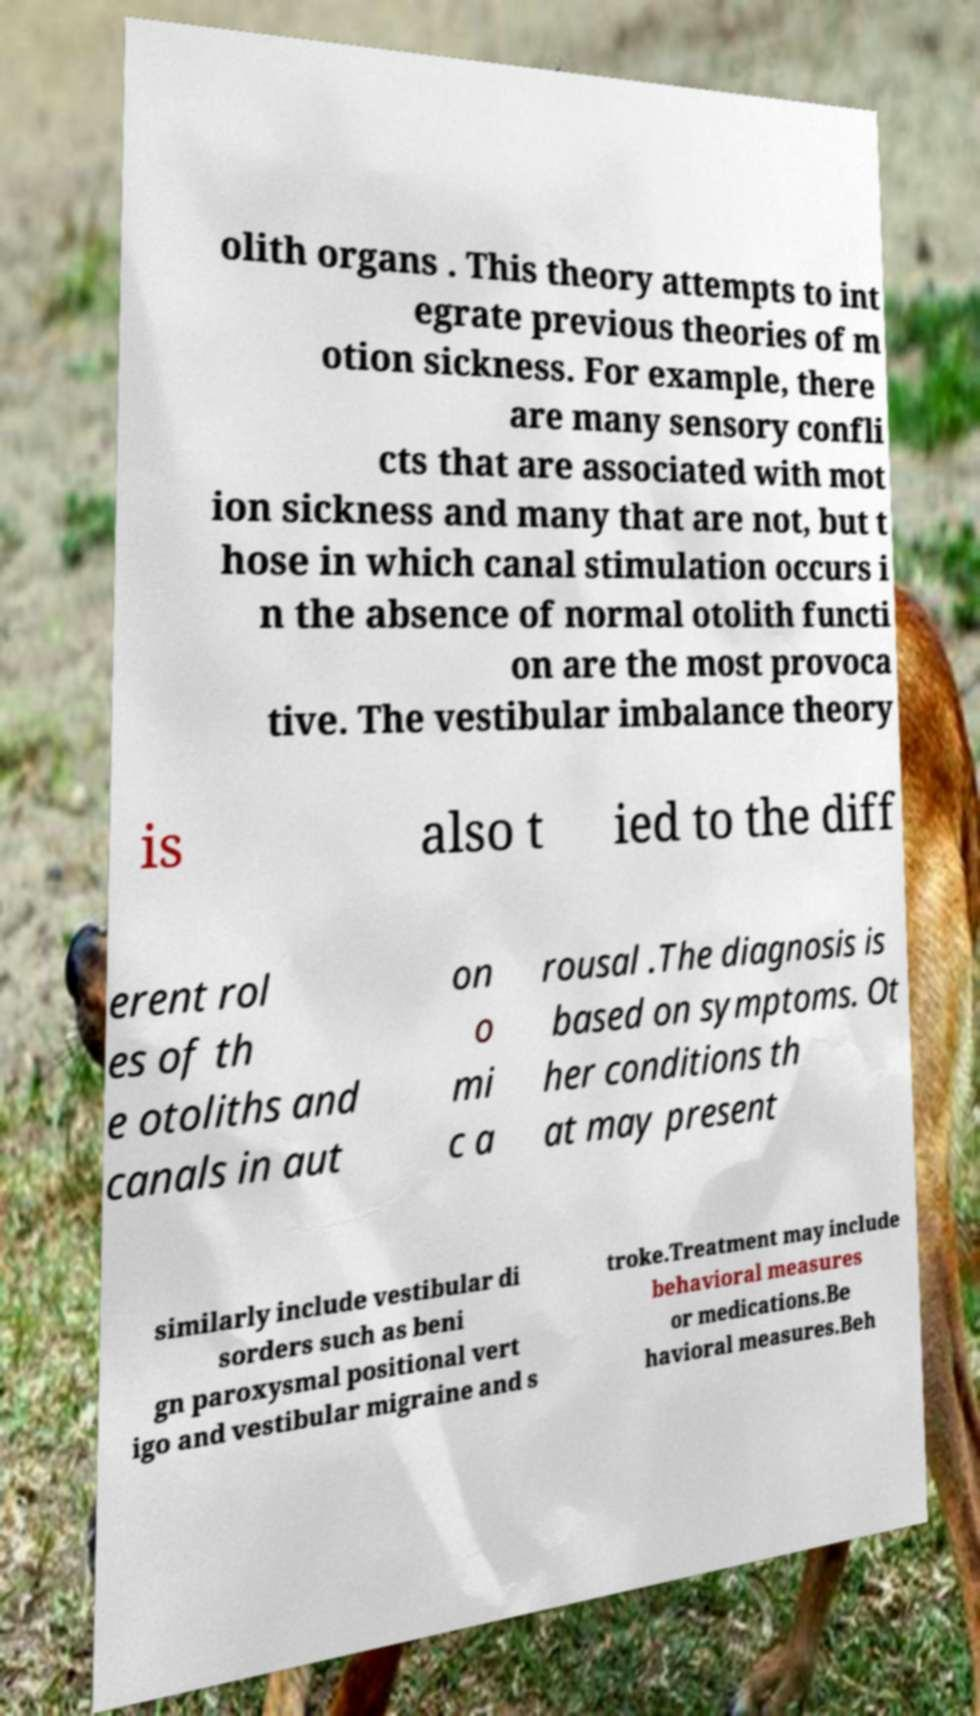Can you read and provide the text displayed in the image?This photo seems to have some interesting text. Can you extract and type it out for me? olith organs . This theory attempts to int egrate previous theories of m otion sickness. For example, there are many sensory confli cts that are associated with mot ion sickness and many that are not, but t hose in which canal stimulation occurs i n the absence of normal otolith functi on are the most provoca tive. The vestibular imbalance theory is also t ied to the diff erent rol es of th e otoliths and canals in aut on o mi c a rousal .The diagnosis is based on symptoms. Ot her conditions th at may present similarly include vestibular di sorders such as beni gn paroxysmal positional vert igo and vestibular migraine and s troke.Treatment may include behavioral measures or medications.Be havioral measures.Beh 